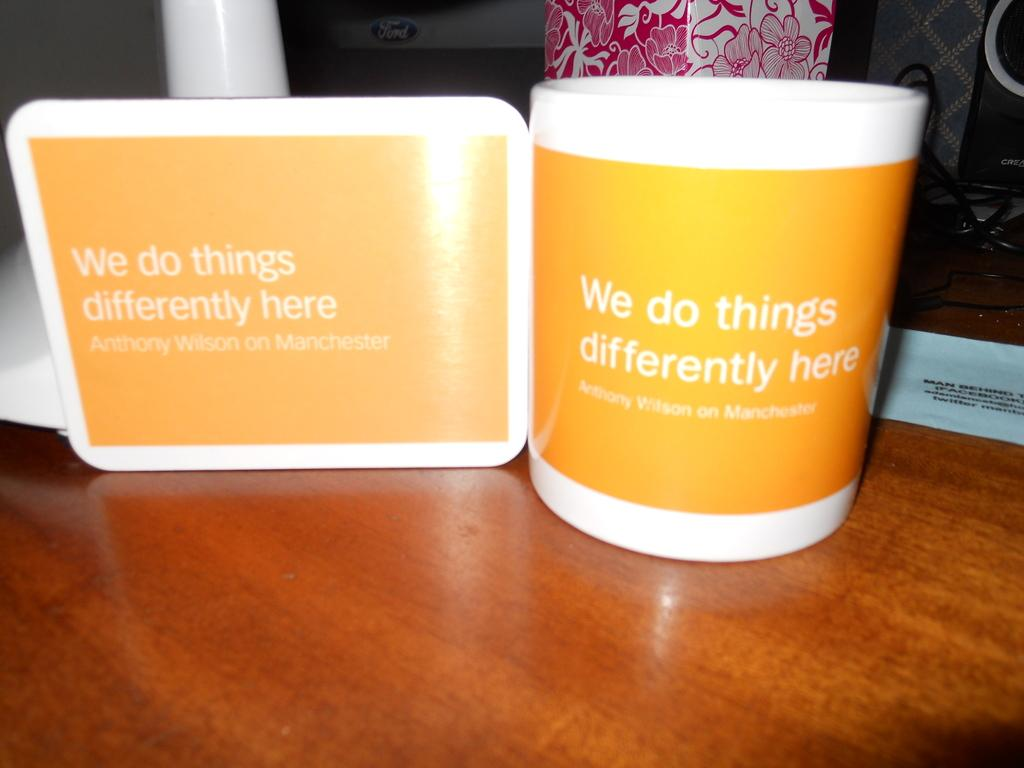<image>
Present a compact description of the photo's key features. Two items displaying the phrase "We do things differently here". 